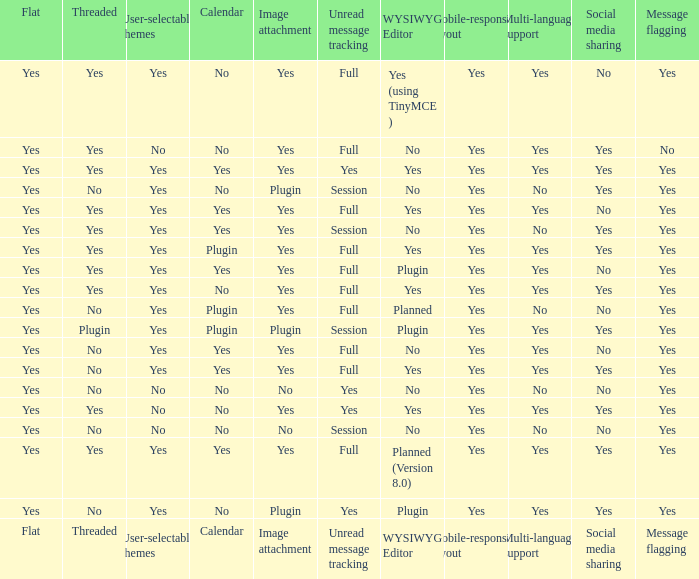Which Image attachment has a Threaded of yes, and a Calendar of yes? Yes, Yes, Yes, Yes, Yes. 